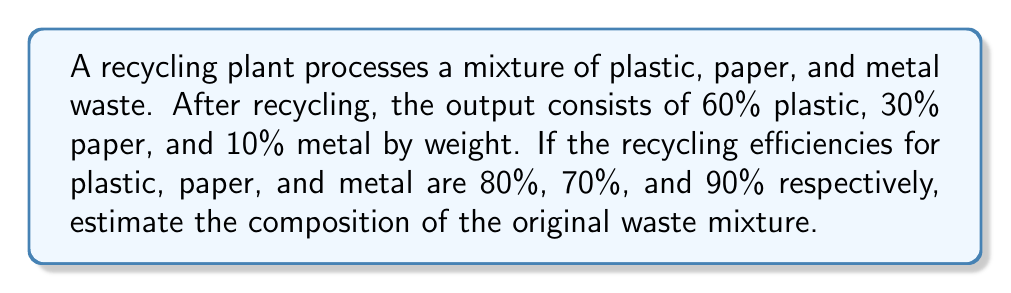Can you solve this math problem? Let's approach this step-by-step using the inverse problem methodology:

1) Let $x$, $y$, and $z$ be the fractions of plastic, paper, and metal in the original mixture, respectively.

2) We know that $x + y + z = 1$ (the total composition must be 100%)

3) Given the recycling efficiencies and output composition, we can set up the following system of equations:

   $$\frac{0.8x}{0.8x + 0.7y + 0.9z} = 0.6$$
   $$\frac{0.7y}{0.8x + 0.7y + 0.9z} = 0.3$$
   $$\frac{0.9z}{0.8x + 0.7y + 0.9z} = 0.1$$

4) From these equations, we can derive:

   $$0.8x = 0.6(0.8x + 0.7y + 0.9z)$$
   $$0.7y = 0.3(0.8x + 0.7y + 0.9z)$$
   $$0.9z = 0.1(0.8x + 0.7y + 0.9z)$$

5) Simplifying:

   $$0.32x = 0.42y + 0.54z$$
   $$0.49y = 0.24x + 0.27z$$
   $$0.81z = 0.08x + 0.07y$$

6) Solving this system of equations along with $x + y + z = 1$, we get:

   $$x \approx 0.5625$$
   $$y \approx 0.3214$$
   $$z \approx 0.1161$$

7) Converting to percentages:

   Plastic: 56.25%
   Paper: 32.14%
   Metal: 11.61%
Answer: 56.25% plastic, 32.14% paper, 11.61% metal 